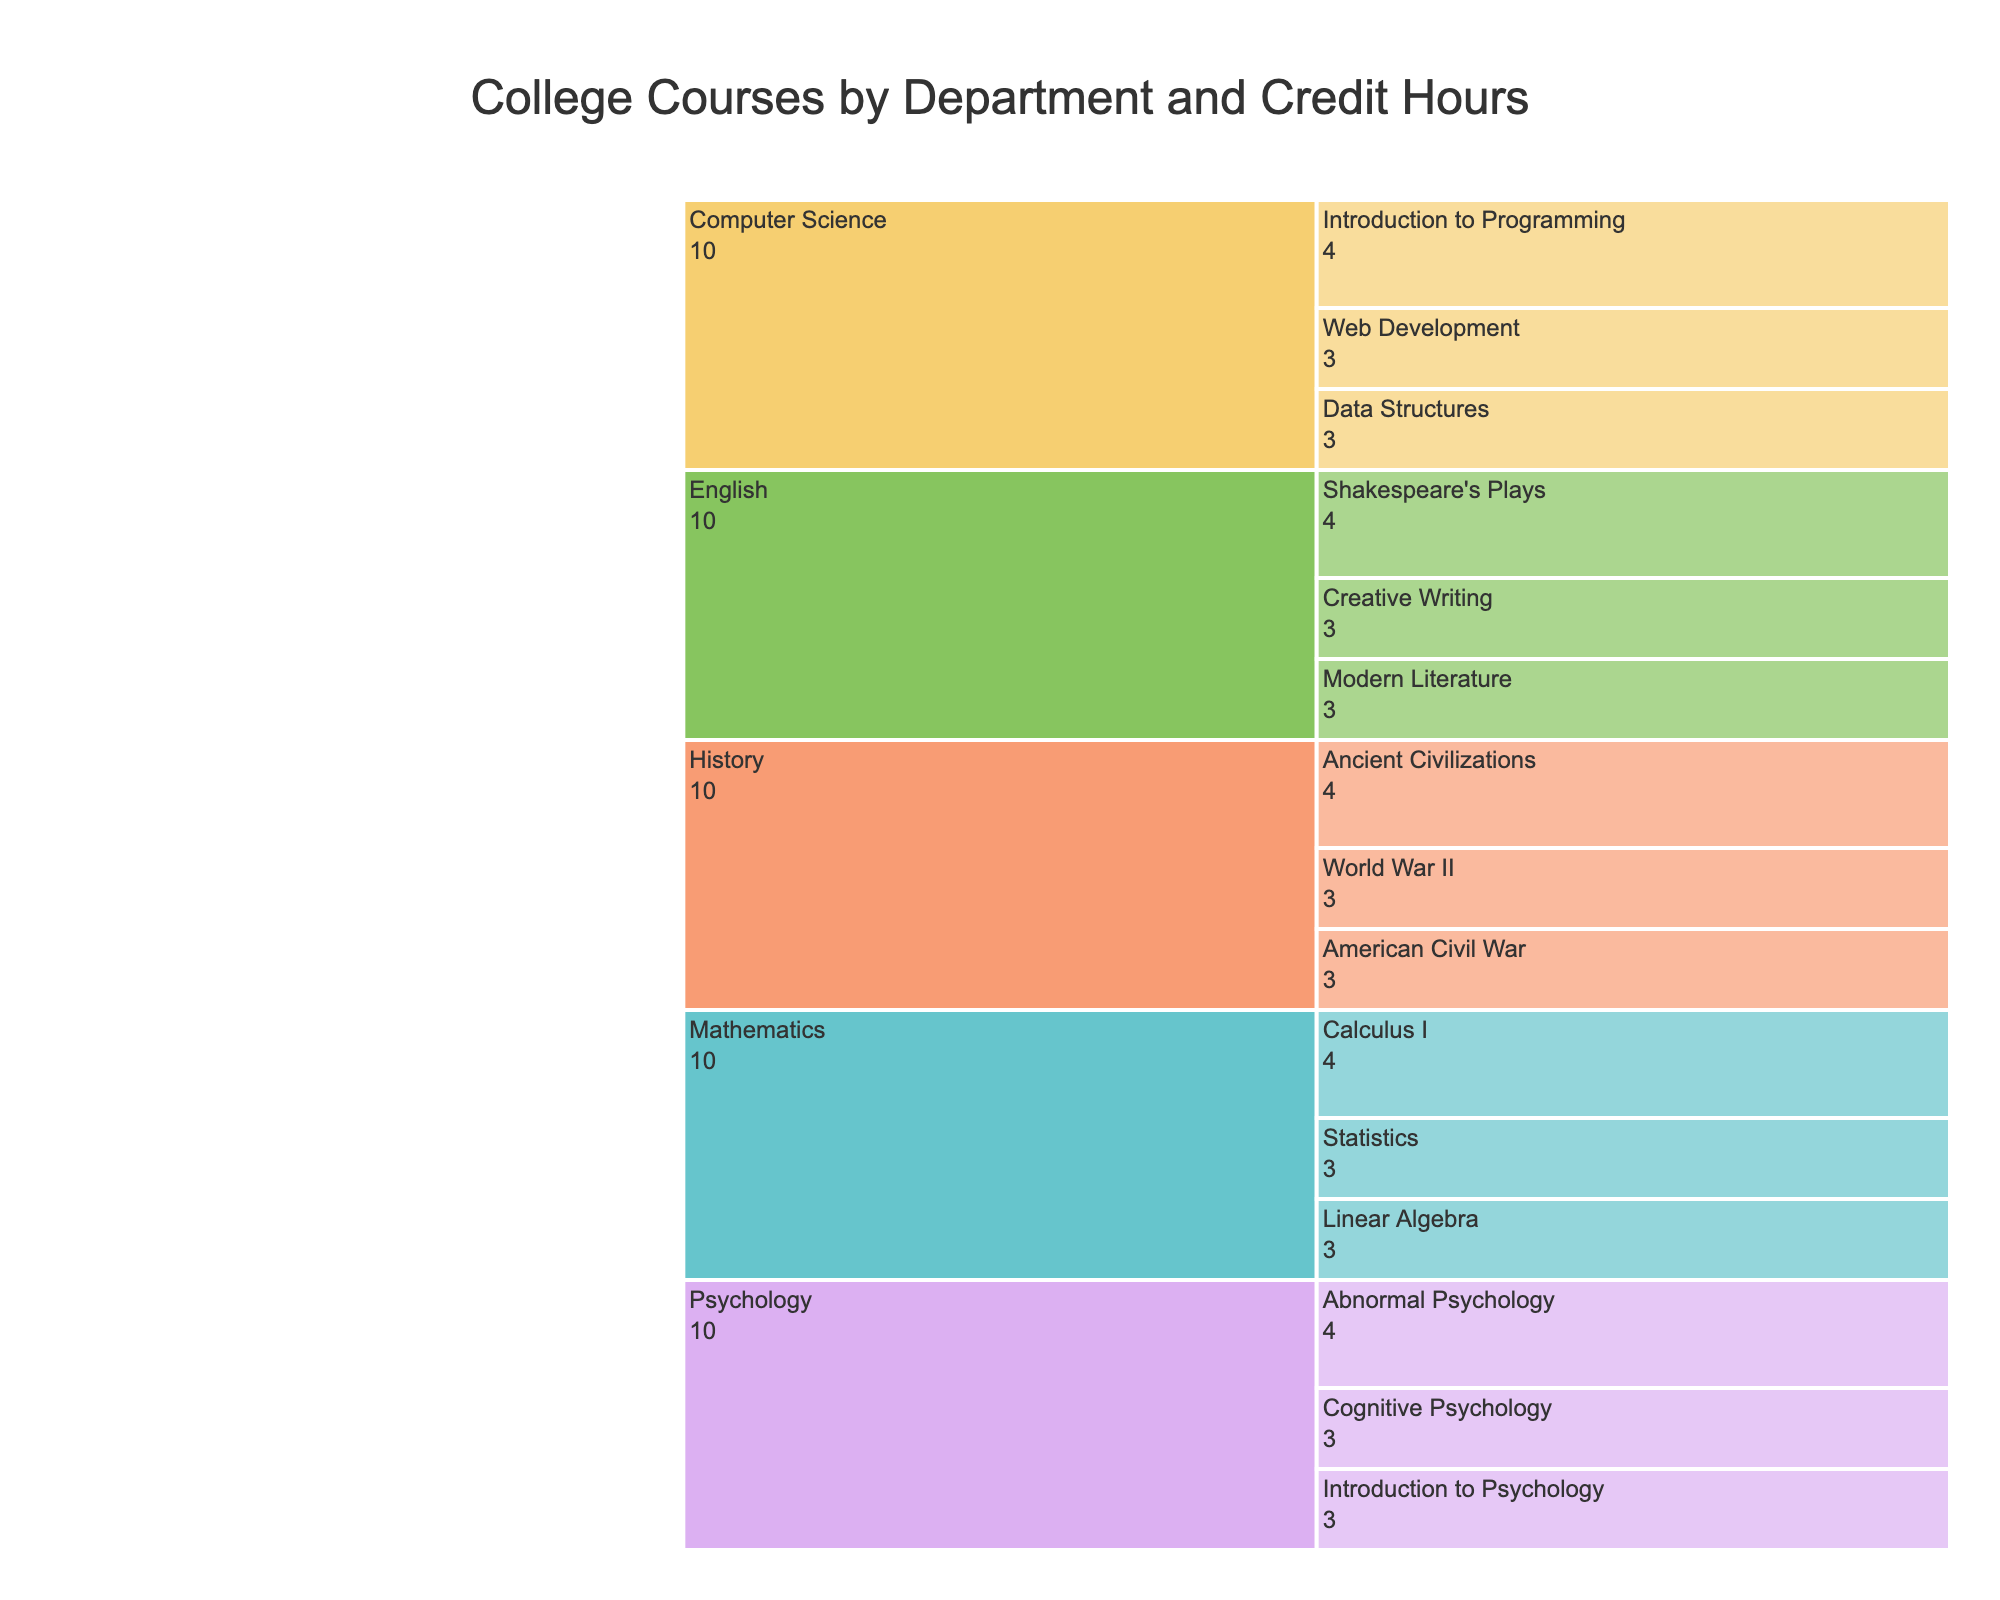Which department has the most total credit hours? Add up the credit hours for each department: History (3+3+4=10), English (3+4+3=10), Mathematics (4+3+3=10), Psychology (3+4+3=10), Computer Science (4+3+3=10). All departments have the same total credit hours of 10.
Answer: All departments What is the title of the chart? Read the title from the top of the chart.
Answer: College Courses by Department and Credit Hours Which course in the History department has the highest credit hours? Compare the credit hours of each course in the History department: American Civil War (3), World War II (3), Ancient Civilizations (4).
Answer: Ancient Civilizations How many credit hours are there for Creative Writing and Modern Literature combined? Add the credit hours of Creative Writing (3) and Modern Literature (3).
Answer: 6 Which two departments have a course with 4 credit hours? Identify the departments with a course that has 4 credit hours. History (Ancient Civilizations), English (Shakespeare's Plays), Mathematics (Calculus I), Psychology (Abnormal Psychology), Computer Science (Introduction to Programming).
Answer: All departments What is the total number of credit hours for all Computer Science courses? Sum the credit hours for the Computer Science courses: Introduction to Programming (4), Data Structures (3), Web Development (3).
Answer: 10 How many courses have exactly 3 credit hours? Count the number of courses with 3 credit hours: American Civil War, World War II, Creative Writing, Modern Literature, Statistics, Linear Algebra, Introduction to Psychology, Cognitive Psychology, Data Structures, Web Development.
Answer: 10 Which course has the most credit hours in the Psychology department? Compare the credit hours of each course in the Psychology department: Introduction to Psychology (3), Abnormal Psychology (4), Cognitive Psychology (3).
Answer: Abnormal Psychology Which department has an equal number of credit hours as the Mathematics department? Identify the departments with total credit hours equal to Mathematics (10): History (10), English (10), Psychology (10), Computer Science (10).
Answer: History, English, Psychology, Computer Science Which course has the least amount of credit hours? Identify the minimum credit hours among all the courses listed, many courses have 3 credit hours.
Answer: Many courses 